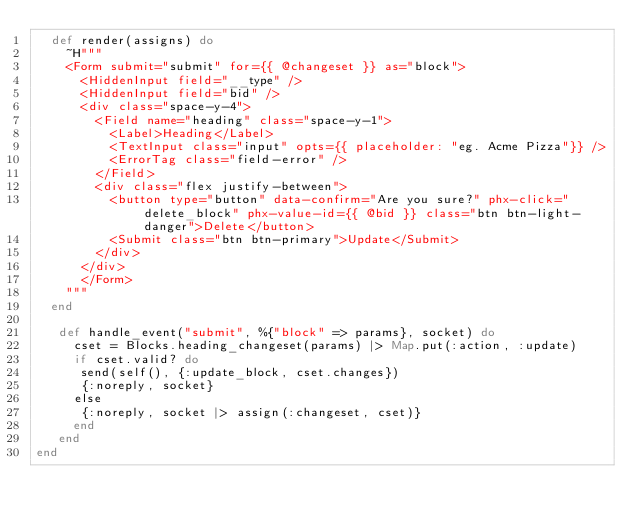<code> <loc_0><loc_0><loc_500><loc_500><_Elixir_>  def render(assigns) do
    ~H"""
    <Form submit="submit" for={{ @changeset }} as="block">
      <HiddenInput field="__type" />
      <HiddenInput field="bid" />
      <div class="space-y-4">
        <Field name="heading" class="space-y-1">
          <Label>Heading</Label>
          <TextInput class="input" opts={{ placeholder: "eg. Acme Pizza"}} />
          <ErrorTag class="field-error" />
        </Field>
        <div class="flex justify-between">
          <button type="button" data-confirm="Are you sure?" phx-click="delete_block" phx-value-id={{ @bid }} class="btn btn-light-danger">Delete</button>
          <Submit class="btn btn-primary">Update</Submit>
        </div>
      </div>
      </Form>
    """
  end

   def handle_event("submit", %{"block" => params}, socket) do
     cset = Blocks.heading_changeset(params) |> Map.put(:action, :update)
     if cset.valid? do
      send(self(), {:update_block, cset.changes})
      {:noreply, socket}
     else
      {:noreply, socket |> assign(:changeset, cset)}
     end
   end
end
</code> 